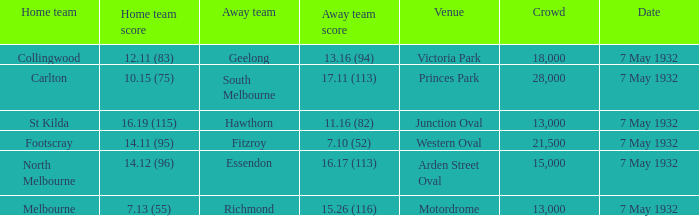What is the offsite team with a spectator count above 13,000, and a home team score of 1 Geelong. 